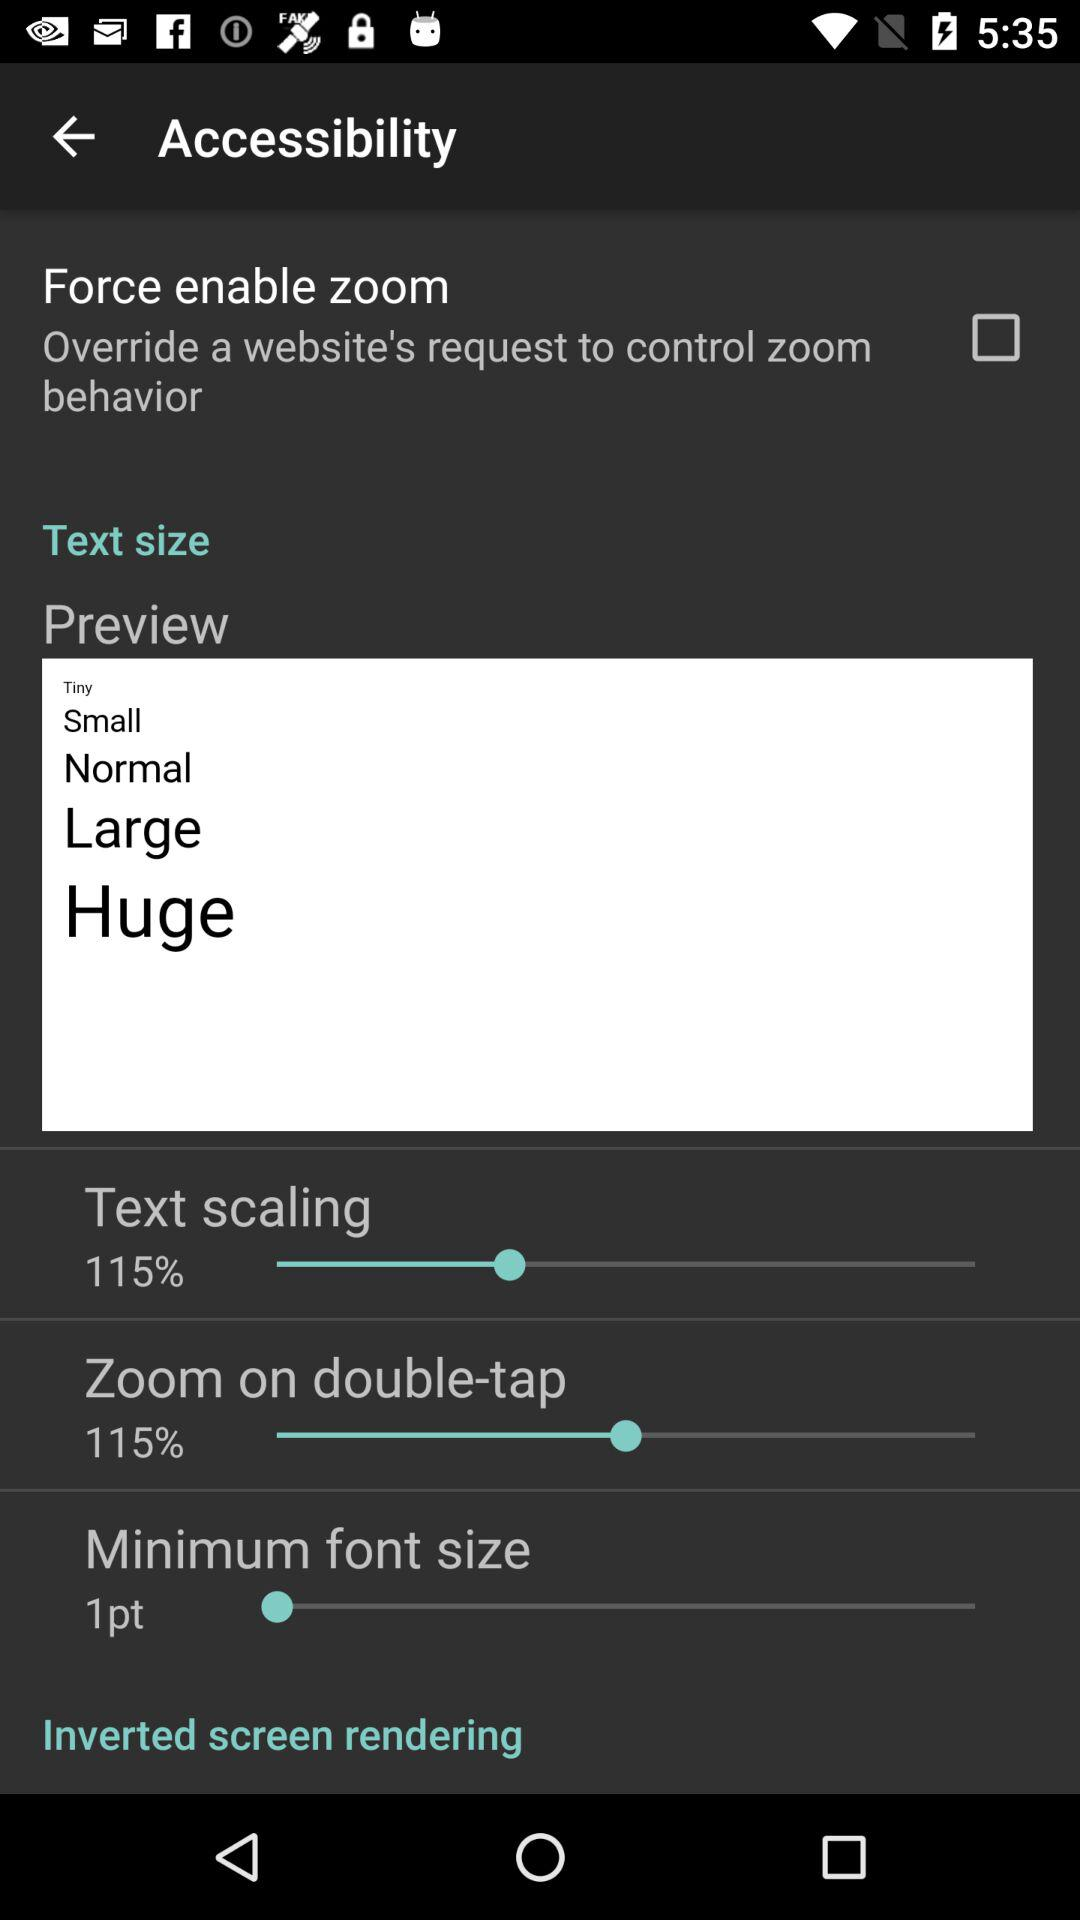Which text sizes are available? The available text sizes are "Tiny", "Small", "Normal", "Large" and "Huge". 